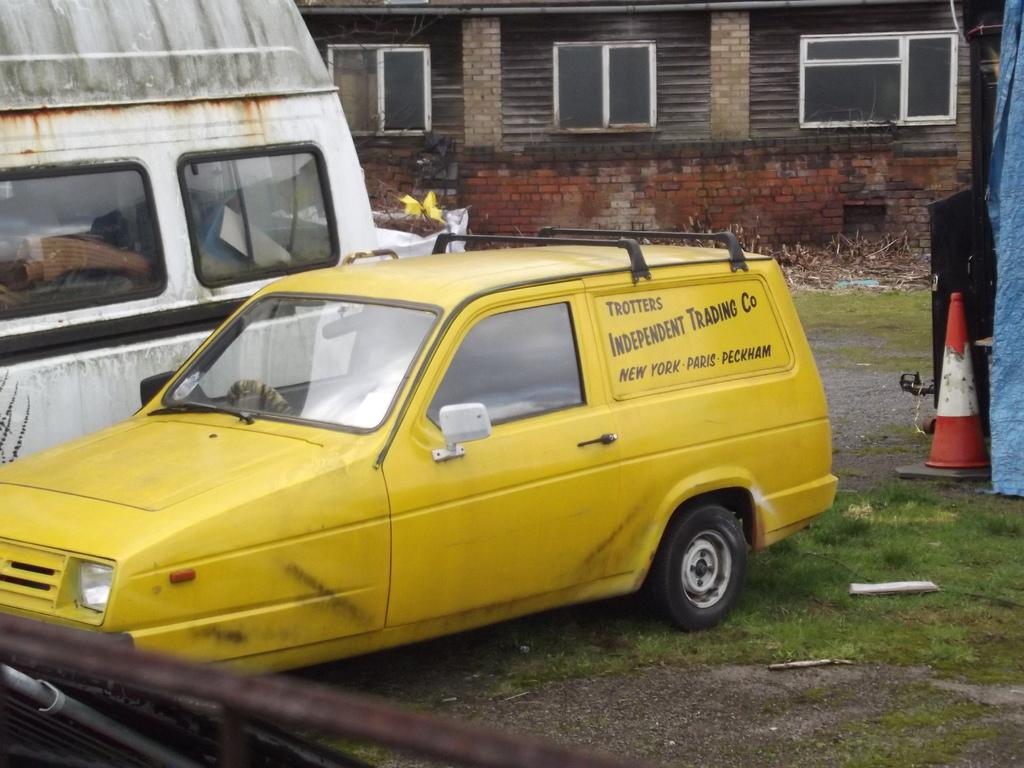<image>
Offer a succinct explanation of the picture presented. A yellow station wagon parked in the grass says Trotters Independent Trading Co. 